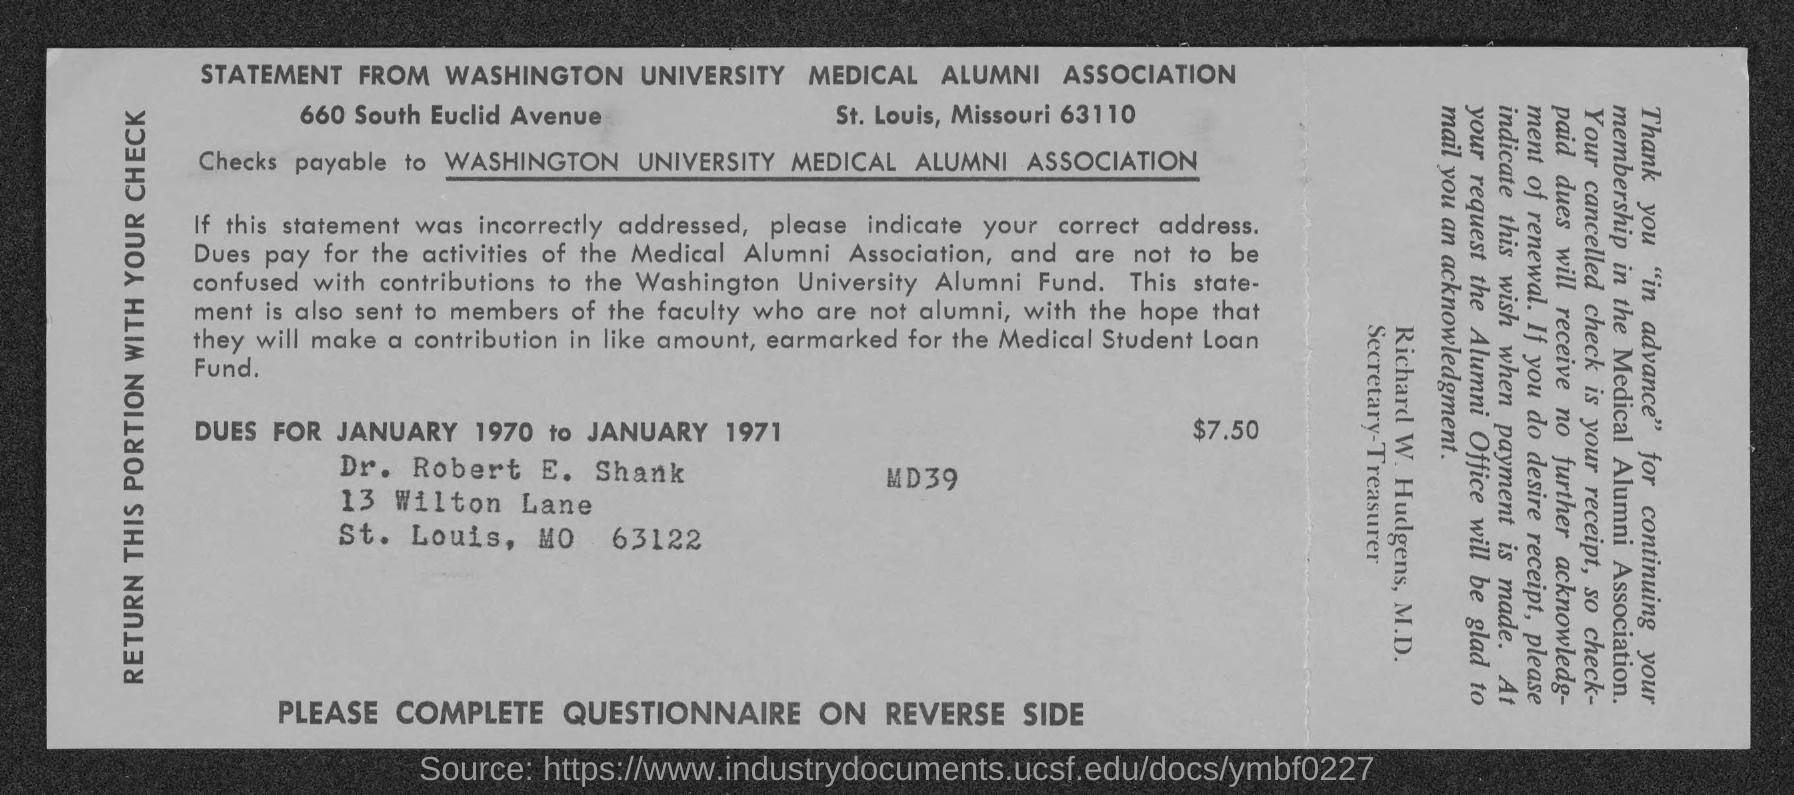Indicate a few pertinent items in this graphic. What is due Amount? The amount is $7.50. 